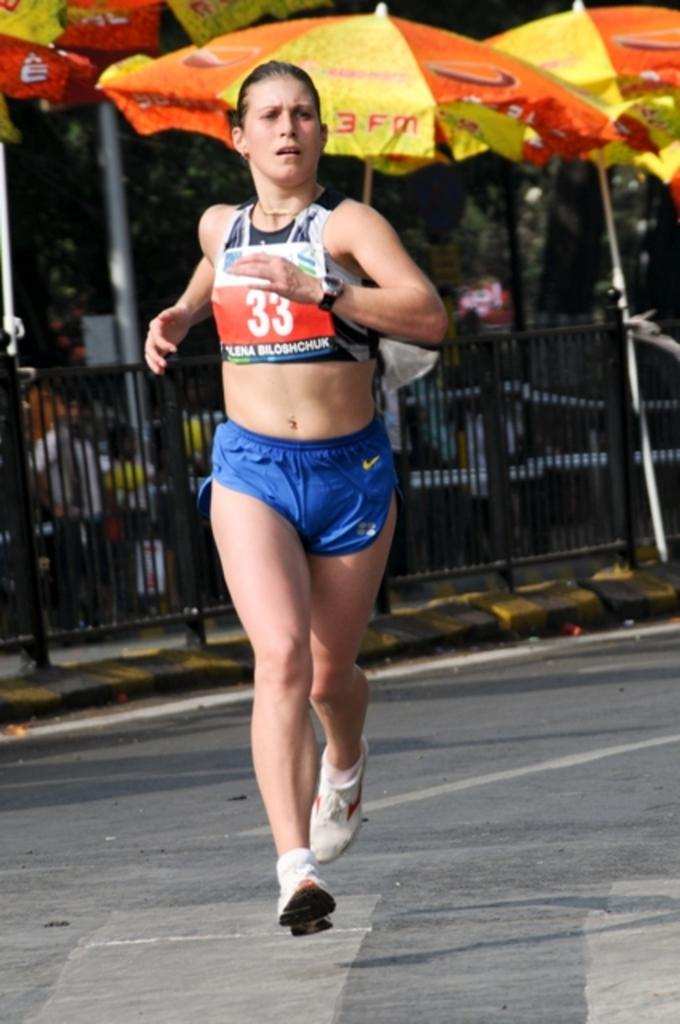<image>
Provide a brief description of the given image. A runner with the number 33 and Elena Biloshchuk on her shirt 